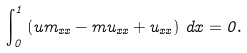<formula> <loc_0><loc_0><loc_500><loc_500>\int _ { 0 } ^ { 1 } \left ( u m _ { x x } - m u _ { x x } + u _ { x x } \right ) \, d x = 0 .</formula> 